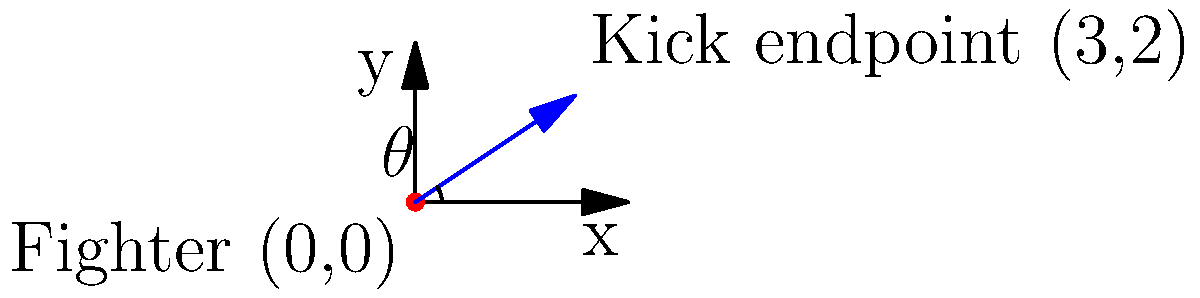In a UFC octagon, a fighter at the origin (0,0) performs a high kick that ends at the point (3,2) in meters. Calculate the angle $\theta$ of the kick from the horizontal using the arctangent function. Round your answer to the nearest degree. To find the angle of the kick, we'll use the arctangent function with the coordinates of the kick's endpoint. Here's how to solve it step-by-step:

1) The kick starts at (0,0) and ends at (3,2).

2) The horizontal distance (adjacent side) is 3 meters.

3) The vertical distance (opposite side) is 2 meters.

4) The formula for calculating the angle using arctangent is:

   $$\theta = \arctan(\frac{\text{opposite}}{\text{adjacent}})$$

5) Plugging in our values:

   $$\theta = \arctan(\frac{2}{3})$$

6) Using a calculator or computer:

   $$\theta \approx 0.5880 \text{ radians}$$

7) Convert radians to degrees:

   $$\theta \approx 0.5880 \times \frac{180^{\circ}}{\pi} \approx 33.69^{\circ}$$

8) Rounding to the nearest degree:

   $$\theta \approx 34^{\circ}$$

Therefore, the angle of the kick from the horizontal is approximately 34 degrees.
Answer: 34° 